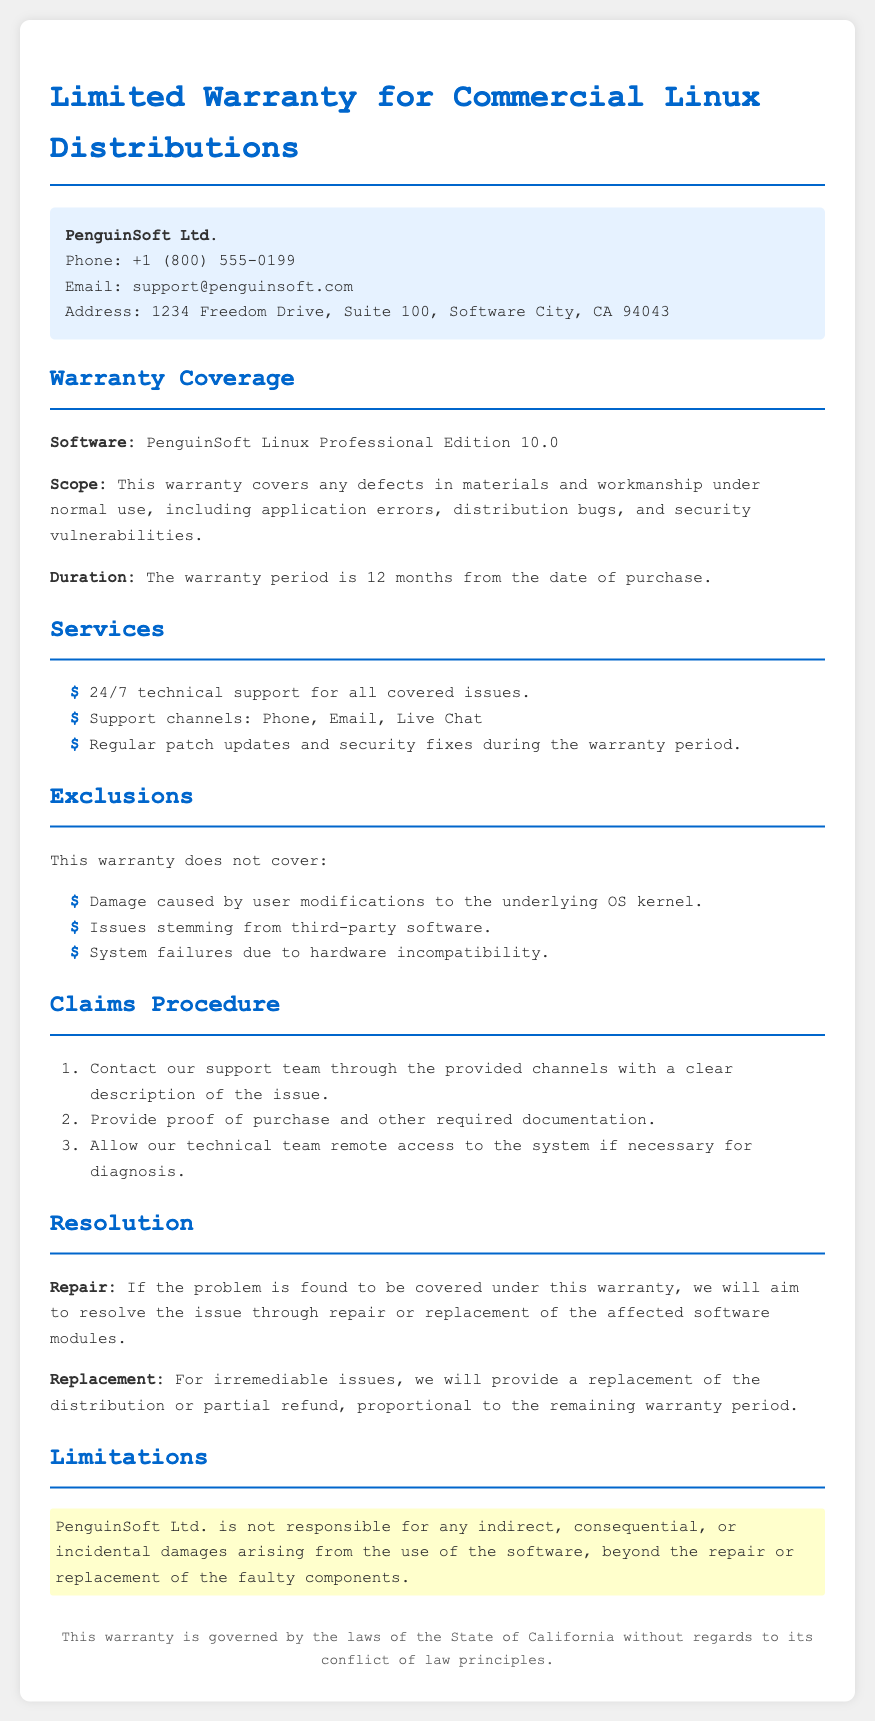what is the software covered by the warranty? The document states that the warranty covers PenguinSoft Linux Professional Edition 10.0.
Answer: PenguinSoft Linux Professional Edition 10.0 how long is the warranty period? The document mentions that the warranty duration is 12 months from the date of purchase.
Answer: 12 months what types of support are provided? The document lists various support channels that are available during the warranty period, including phone, email, and live chat.
Answer: 24/7 technical support what is excluded from the warranty coverage? The document specifies exclusions, such as damage caused by user modifications to the underlying OS kernel and issues from third-party software.
Answer: Damage caused by user modifications how should a claim be initiated? The document outlines that claims should start by contacting the support team with a clear description of the issue.
Answer: Contact support team what happens if the issue cannot be repaired? The document states that for irremediable issues, a replacement or partial refund will be provided.
Answer: Replacement or partial refund who is the manufacturer of the software? The document includes the name of the company providing the warranty.
Answer: PenguinSoft Ltd where is the company's support email located? The contact information section in the document provides the support email.
Answer: support@penguinsoft.com 